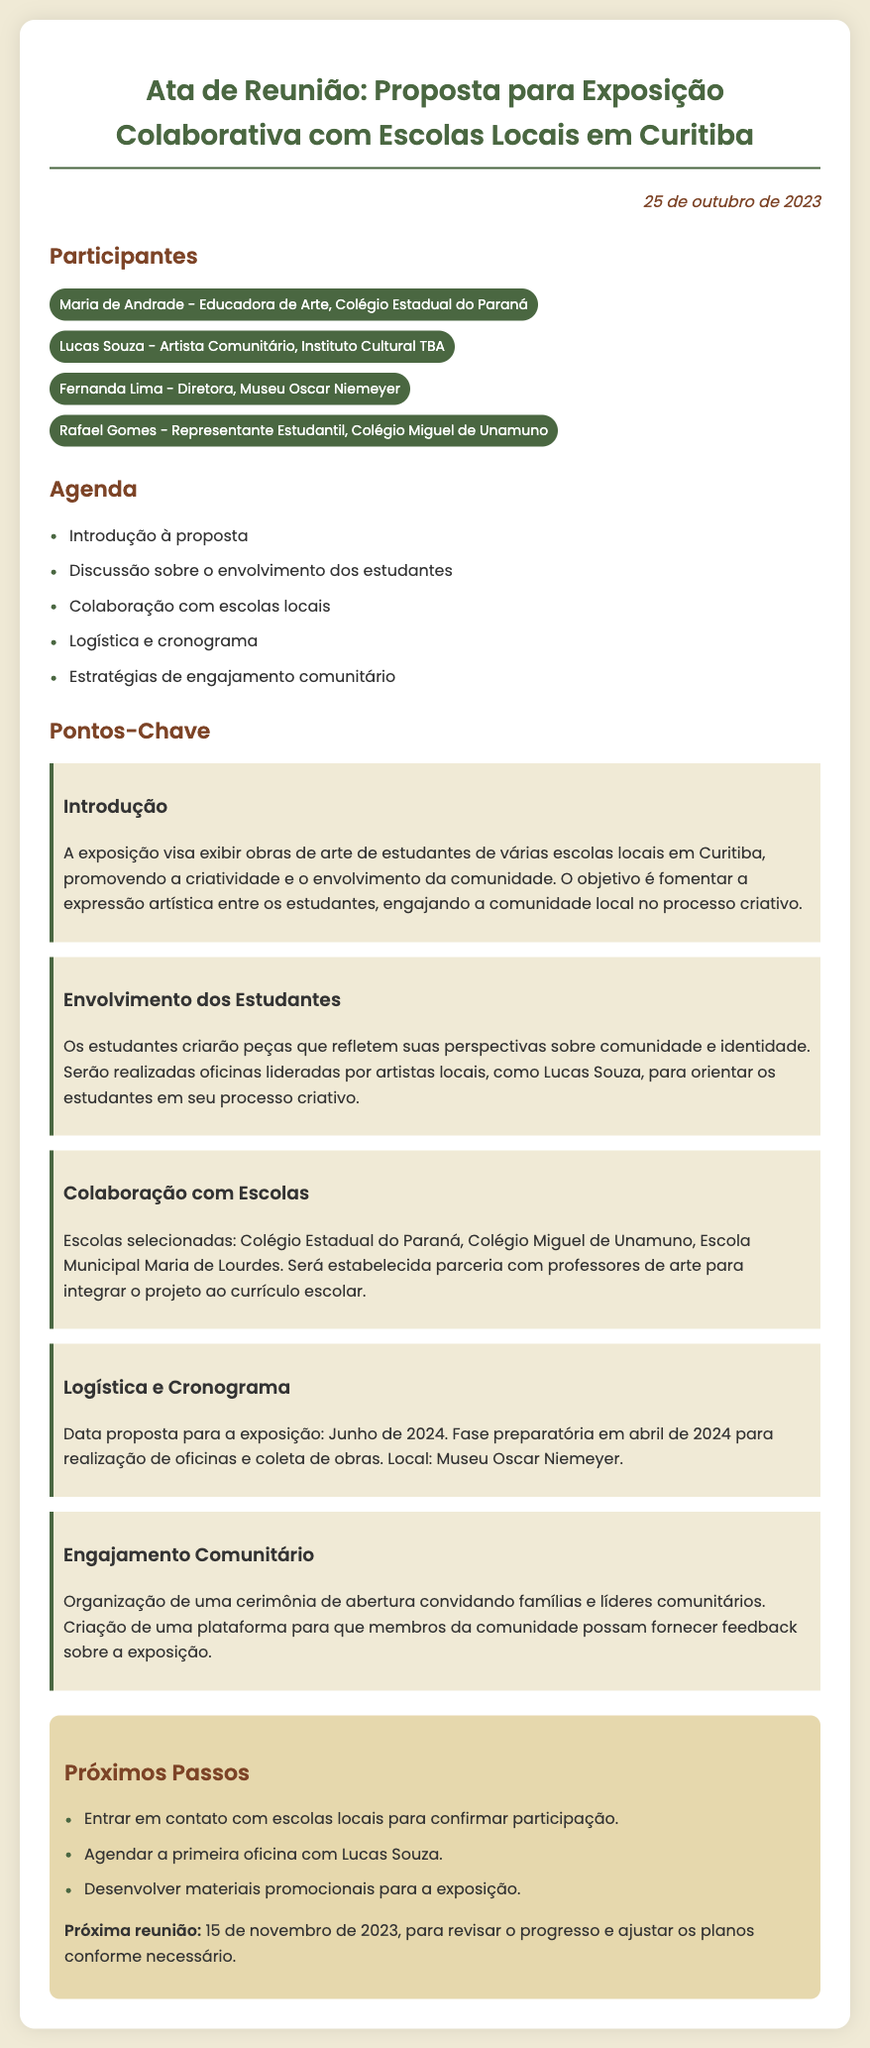qual é a data da reunião? A data da reunião é mencionada na parte superior do documento.
Answer: 25 de outubro de 2023 quem é o educador de arte presente na reunião? O nome do educador de arte está listado na seção de participantes.
Answer: Maria de Andrade qual é a data proposta para a exposição? A data proposta para a exposição está mencionada na seção de logística e cronograma.
Answer: Junho de 2024 quais escolas estão selecionadas para a colaboração? As escolas escolhidas são mencionadas no ponto sobre colaboração com escolas.
Answer: Colégio Estadual do Paraná, Colégio Miguel de Unamuno, Escola Municipal Maria de Lourdes quem liderará as oficinas para os estudantes? O nome da pessoa que liderará as oficinas é destacado na parte que fala sobre o envolvimento dos estudantes.
Answer: Lucas Souza como será feito o engajamento comunitário? A seção sobre engajamento comunitário fornece detalhes sobre como isso será realizado.
Answer: Cerimônia de abertura qual é o próximo passo mencionado? A seção de próximos passos contém uma lista das ações a serem realizadas.
Answer: Entrar em contato com escolas locais para confirmar participação 